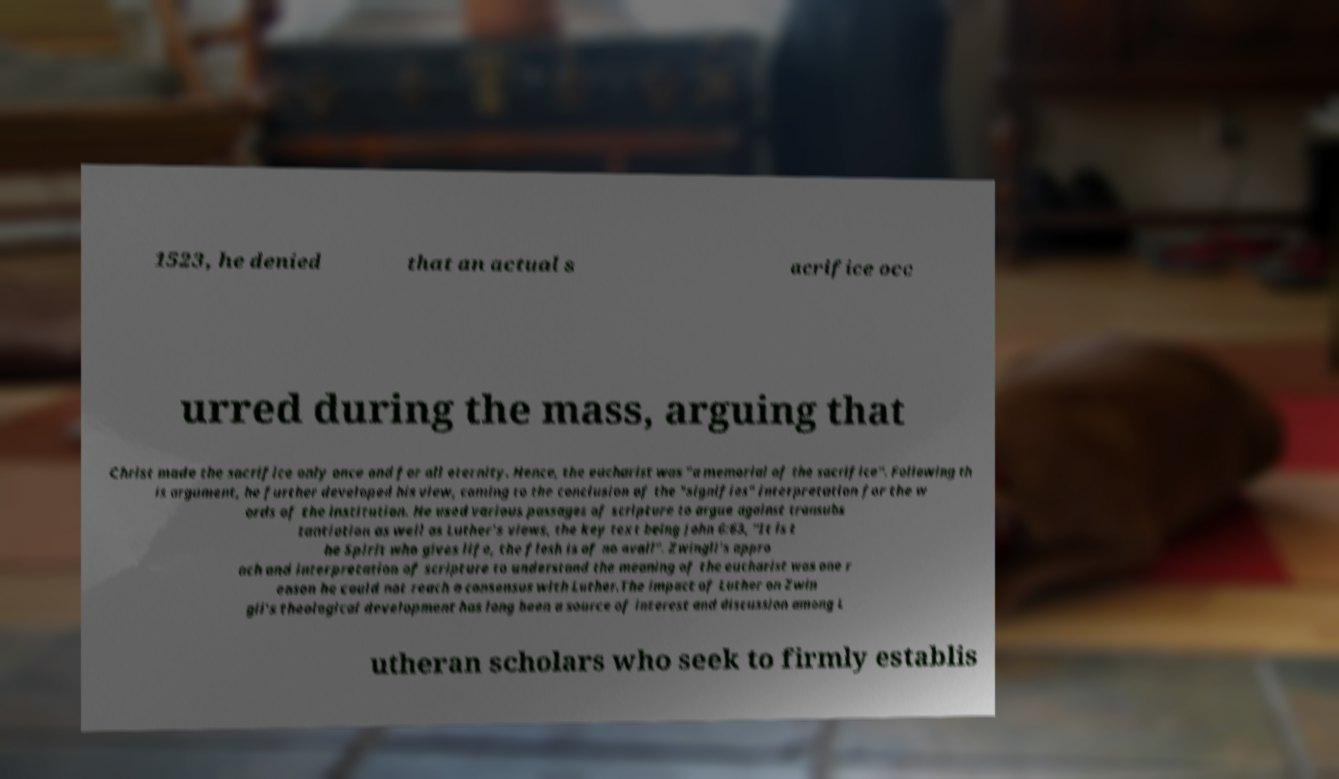There's text embedded in this image that I need extracted. Can you transcribe it verbatim? 1523, he denied that an actual s acrifice occ urred during the mass, arguing that Christ made the sacrifice only once and for all eternity. Hence, the eucharist was "a memorial of the sacrifice". Following th is argument, he further developed his view, coming to the conclusion of the "signifies" interpretation for the w ords of the institution. He used various passages of scripture to argue against transubs tantiation as well as Luther's views, the key text being John 6:63, "It is t he Spirit who gives life, the flesh is of no avail". Zwingli's appro ach and interpretation of scripture to understand the meaning of the eucharist was one r eason he could not reach a consensus with Luther.The impact of Luther on Zwin gli's theological development has long been a source of interest and discussion among L utheran scholars who seek to firmly establis 